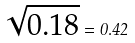<formula> <loc_0><loc_0><loc_500><loc_500>\sqrt { 0 . 1 8 } = 0 . 4 2</formula> 